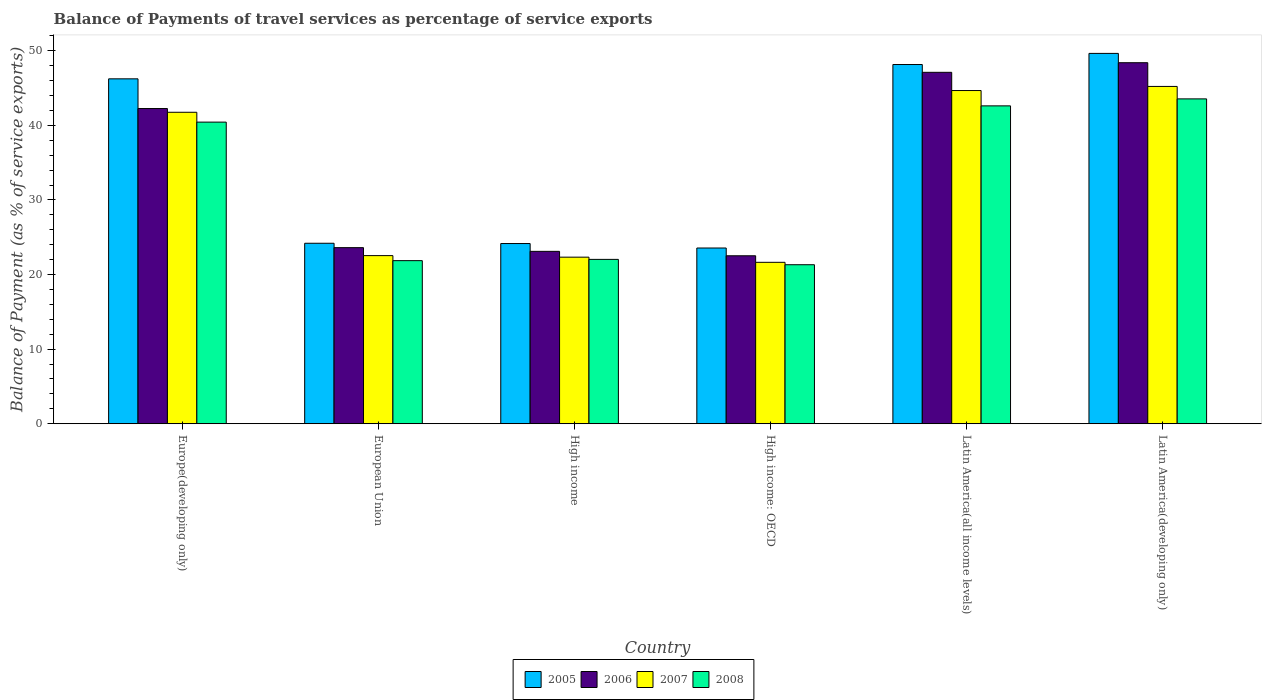How many different coloured bars are there?
Keep it short and to the point. 4. Are the number of bars per tick equal to the number of legend labels?
Provide a succinct answer. Yes. Are the number of bars on each tick of the X-axis equal?
Offer a very short reply. Yes. How many bars are there on the 1st tick from the left?
Your answer should be very brief. 4. How many bars are there on the 3rd tick from the right?
Give a very brief answer. 4. What is the label of the 4th group of bars from the left?
Offer a very short reply. High income: OECD. What is the balance of payments of travel services in 2005 in High income: OECD?
Keep it short and to the point. 23.56. Across all countries, what is the maximum balance of payments of travel services in 2008?
Offer a terse response. 43.55. Across all countries, what is the minimum balance of payments of travel services in 2008?
Provide a succinct answer. 21.32. In which country was the balance of payments of travel services in 2006 maximum?
Your answer should be very brief. Latin America(developing only). In which country was the balance of payments of travel services in 2007 minimum?
Offer a very short reply. High income: OECD. What is the total balance of payments of travel services in 2007 in the graph?
Make the answer very short. 198.15. What is the difference between the balance of payments of travel services in 2006 in High income and that in Latin America(developing only)?
Your answer should be very brief. -25.29. What is the difference between the balance of payments of travel services in 2006 in High income and the balance of payments of travel services in 2008 in Europe(developing only)?
Make the answer very short. -17.33. What is the average balance of payments of travel services in 2006 per country?
Your answer should be very brief. 34.5. What is the difference between the balance of payments of travel services of/in 2007 and balance of payments of travel services of/in 2008 in Latin America(developing only)?
Provide a short and direct response. 1.67. What is the ratio of the balance of payments of travel services in 2007 in Latin America(all income levels) to that in Latin America(developing only)?
Your answer should be very brief. 0.99. Is the balance of payments of travel services in 2006 in Europe(developing only) less than that in High income?
Offer a terse response. No. Is the difference between the balance of payments of travel services in 2007 in High income and Latin America(developing only) greater than the difference between the balance of payments of travel services in 2008 in High income and Latin America(developing only)?
Give a very brief answer. No. What is the difference between the highest and the second highest balance of payments of travel services in 2005?
Your answer should be compact. -1.49. What is the difference between the highest and the lowest balance of payments of travel services in 2007?
Your response must be concise. 23.58. Is the sum of the balance of payments of travel services in 2007 in High income and Latin America(developing only) greater than the maximum balance of payments of travel services in 2005 across all countries?
Offer a terse response. Yes. Is it the case that in every country, the sum of the balance of payments of travel services in 2008 and balance of payments of travel services in 2007 is greater than the sum of balance of payments of travel services in 2005 and balance of payments of travel services in 2006?
Provide a short and direct response. No. How many bars are there?
Keep it short and to the point. 24. Are the values on the major ticks of Y-axis written in scientific E-notation?
Your answer should be very brief. No. Does the graph contain any zero values?
Your response must be concise. No. Where does the legend appear in the graph?
Provide a short and direct response. Bottom center. How are the legend labels stacked?
Your answer should be compact. Horizontal. What is the title of the graph?
Provide a succinct answer. Balance of Payments of travel services as percentage of service exports. What is the label or title of the Y-axis?
Your response must be concise. Balance of Payment (as % of service exports). What is the Balance of Payment (as % of service exports) in 2005 in Europe(developing only)?
Give a very brief answer. 46.24. What is the Balance of Payment (as % of service exports) in 2006 in Europe(developing only)?
Make the answer very short. 42.25. What is the Balance of Payment (as % of service exports) of 2007 in Europe(developing only)?
Provide a succinct answer. 41.76. What is the Balance of Payment (as % of service exports) in 2008 in Europe(developing only)?
Provide a short and direct response. 40.43. What is the Balance of Payment (as % of service exports) of 2005 in European Union?
Provide a succinct answer. 24.19. What is the Balance of Payment (as % of service exports) in 2006 in European Union?
Offer a very short reply. 23.61. What is the Balance of Payment (as % of service exports) of 2007 in European Union?
Make the answer very short. 22.54. What is the Balance of Payment (as % of service exports) in 2008 in European Union?
Offer a very short reply. 21.86. What is the Balance of Payment (as % of service exports) of 2005 in High income?
Provide a short and direct response. 24.16. What is the Balance of Payment (as % of service exports) of 2006 in High income?
Your answer should be compact. 23.11. What is the Balance of Payment (as % of service exports) in 2007 in High income?
Give a very brief answer. 22.33. What is the Balance of Payment (as % of service exports) of 2008 in High income?
Give a very brief answer. 22.03. What is the Balance of Payment (as % of service exports) in 2005 in High income: OECD?
Your answer should be compact. 23.56. What is the Balance of Payment (as % of service exports) of 2006 in High income: OECD?
Your answer should be compact. 22.52. What is the Balance of Payment (as % of service exports) of 2007 in High income: OECD?
Provide a short and direct response. 21.64. What is the Balance of Payment (as % of service exports) in 2008 in High income: OECD?
Your response must be concise. 21.32. What is the Balance of Payment (as % of service exports) in 2005 in Latin America(all income levels)?
Provide a short and direct response. 48.16. What is the Balance of Payment (as % of service exports) of 2006 in Latin America(all income levels)?
Your answer should be compact. 47.11. What is the Balance of Payment (as % of service exports) in 2007 in Latin America(all income levels)?
Ensure brevity in your answer.  44.67. What is the Balance of Payment (as % of service exports) in 2008 in Latin America(all income levels)?
Make the answer very short. 42.61. What is the Balance of Payment (as % of service exports) in 2005 in Latin America(developing only)?
Provide a short and direct response. 49.65. What is the Balance of Payment (as % of service exports) in 2006 in Latin America(developing only)?
Your response must be concise. 48.4. What is the Balance of Payment (as % of service exports) in 2007 in Latin America(developing only)?
Give a very brief answer. 45.22. What is the Balance of Payment (as % of service exports) in 2008 in Latin America(developing only)?
Your response must be concise. 43.55. Across all countries, what is the maximum Balance of Payment (as % of service exports) in 2005?
Ensure brevity in your answer.  49.65. Across all countries, what is the maximum Balance of Payment (as % of service exports) in 2006?
Keep it short and to the point. 48.4. Across all countries, what is the maximum Balance of Payment (as % of service exports) of 2007?
Offer a terse response. 45.22. Across all countries, what is the maximum Balance of Payment (as % of service exports) of 2008?
Your answer should be very brief. 43.55. Across all countries, what is the minimum Balance of Payment (as % of service exports) in 2005?
Make the answer very short. 23.56. Across all countries, what is the minimum Balance of Payment (as % of service exports) of 2006?
Provide a succinct answer. 22.52. Across all countries, what is the minimum Balance of Payment (as % of service exports) in 2007?
Your answer should be very brief. 21.64. Across all countries, what is the minimum Balance of Payment (as % of service exports) in 2008?
Give a very brief answer. 21.32. What is the total Balance of Payment (as % of service exports) of 2005 in the graph?
Your response must be concise. 215.95. What is the total Balance of Payment (as % of service exports) of 2006 in the graph?
Ensure brevity in your answer.  206.99. What is the total Balance of Payment (as % of service exports) of 2007 in the graph?
Provide a succinct answer. 198.15. What is the total Balance of Payment (as % of service exports) of 2008 in the graph?
Your response must be concise. 191.81. What is the difference between the Balance of Payment (as % of service exports) of 2005 in Europe(developing only) and that in European Union?
Offer a very short reply. 22.04. What is the difference between the Balance of Payment (as % of service exports) of 2006 in Europe(developing only) and that in European Union?
Provide a succinct answer. 18.65. What is the difference between the Balance of Payment (as % of service exports) of 2007 in Europe(developing only) and that in European Union?
Your answer should be compact. 19.22. What is the difference between the Balance of Payment (as % of service exports) in 2008 in Europe(developing only) and that in European Union?
Provide a succinct answer. 18.57. What is the difference between the Balance of Payment (as % of service exports) in 2005 in Europe(developing only) and that in High income?
Keep it short and to the point. 22.08. What is the difference between the Balance of Payment (as % of service exports) in 2006 in Europe(developing only) and that in High income?
Give a very brief answer. 19.15. What is the difference between the Balance of Payment (as % of service exports) in 2007 in Europe(developing only) and that in High income?
Give a very brief answer. 19.42. What is the difference between the Balance of Payment (as % of service exports) of 2008 in Europe(developing only) and that in High income?
Offer a terse response. 18.4. What is the difference between the Balance of Payment (as % of service exports) in 2005 in Europe(developing only) and that in High income: OECD?
Provide a short and direct response. 22.68. What is the difference between the Balance of Payment (as % of service exports) in 2006 in Europe(developing only) and that in High income: OECD?
Keep it short and to the point. 19.74. What is the difference between the Balance of Payment (as % of service exports) of 2007 in Europe(developing only) and that in High income: OECD?
Make the answer very short. 20.12. What is the difference between the Balance of Payment (as % of service exports) of 2008 in Europe(developing only) and that in High income: OECD?
Ensure brevity in your answer.  19.12. What is the difference between the Balance of Payment (as % of service exports) in 2005 in Europe(developing only) and that in Latin America(all income levels)?
Provide a succinct answer. -1.92. What is the difference between the Balance of Payment (as % of service exports) of 2006 in Europe(developing only) and that in Latin America(all income levels)?
Your answer should be compact. -4.85. What is the difference between the Balance of Payment (as % of service exports) in 2007 in Europe(developing only) and that in Latin America(all income levels)?
Provide a short and direct response. -2.91. What is the difference between the Balance of Payment (as % of service exports) of 2008 in Europe(developing only) and that in Latin America(all income levels)?
Keep it short and to the point. -2.18. What is the difference between the Balance of Payment (as % of service exports) of 2005 in Europe(developing only) and that in Latin America(developing only)?
Give a very brief answer. -3.41. What is the difference between the Balance of Payment (as % of service exports) in 2006 in Europe(developing only) and that in Latin America(developing only)?
Your answer should be compact. -6.14. What is the difference between the Balance of Payment (as % of service exports) in 2007 in Europe(developing only) and that in Latin America(developing only)?
Your answer should be compact. -3.46. What is the difference between the Balance of Payment (as % of service exports) of 2008 in Europe(developing only) and that in Latin America(developing only)?
Your response must be concise. -3.11. What is the difference between the Balance of Payment (as % of service exports) of 2005 in European Union and that in High income?
Your response must be concise. 0.04. What is the difference between the Balance of Payment (as % of service exports) in 2006 in European Union and that in High income?
Your answer should be compact. 0.5. What is the difference between the Balance of Payment (as % of service exports) in 2007 in European Union and that in High income?
Ensure brevity in your answer.  0.21. What is the difference between the Balance of Payment (as % of service exports) of 2008 in European Union and that in High income?
Keep it short and to the point. -0.17. What is the difference between the Balance of Payment (as % of service exports) in 2005 in European Union and that in High income: OECD?
Give a very brief answer. 0.64. What is the difference between the Balance of Payment (as % of service exports) of 2006 in European Union and that in High income: OECD?
Offer a terse response. 1.09. What is the difference between the Balance of Payment (as % of service exports) in 2007 in European Union and that in High income: OECD?
Your response must be concise. 0.9. What is the difference between the Balance of Payment (as % of service exports) in 2008 in European Union and that in High income: OECD?
Your answer should be very brief. 0.55. What is the difference between the Balance of Payment (as % of service exports) of 2005 in European Union and that in Latin America(all income levels)?
Your answer should be very brief. -23.96. What is the difference between the Balance of Payment (as % of service exports) of 2006 in European Union and that in Latin America(all income levels)?
Ensure brevity in your answer.  -23.5. What is the difference between the Balance of Payment (as % of service exports) of 2007 in European Union and that in Latin America(all income levels)?
Give a very brief answer. -22.13. What is the difference between the Balance of Payment (as % of service exports) of 2008 in European Union and that in Latin America(all income levels)?
Make the answer very short. -20.75. What is the difference between the Balance of Payment (as % of service exports) in 2005 in European Union and that in Latin America(developing only)?
Offer a very short reply. -25.45. What is the difference between the Balance of Payment (as % of service exports) in 2006 in European Union and that in Latin America(developing only)?
Make the answer very short. -24.79. What is the difference between the Balance of Payment (as % of service exports) of 2007 in European Union and that in Latin America(developing only)?
Ensure brevity in your answer.  -22.68. What is the difference between the Balance of Payment (as % of service exports) of 2008 in European Union and that in Latin America(developing only)?
Your answer should be very brief. -21.68. What is the difference between the Balance of Payment (as % of service exports) in 2005 in High income and that in High income: OECD?
Provide a short and direct response. 0.6. What is the difference between the Balance of Payment (as % of service exports) in 2006 in High income and that in High income: OECD?
Provide a succinct answer. 0.59. What is the difference between the Balance of Payment (as % of service exports) in 2007 in High income and that in High income: OECD?
Make the answer very short. 0.69. What is the difference between the Balance of Payment (as % of service exports) of 2008 in High income and that in High income: OECD?
Offer a terse response. 0.72. What is the difference between the Balance of Payment (as % of service exports) in 2005 in High income and that in Latin America(all income levels)?
Your answer should be compact. -24. What is the difference between the Balance of Payment (as % of service exports) in 2006 in High income and that in Latin America(all income levels)?
Keep it short and to the point. -24. What is the difference between the Balance of Payment (as % of service exports) in 2007 in High income and that in Latin America(all income levels)?
Your answer should be compact. -22.34. What is the difference between the Balance of Payment (as % of service exports) of 2008 in High income and that in Latin America(all income levels)?
Provide a short and direct response. -20.58. What is the difference between the Balance of Payment (as % of service exports) in 2005 in High income and that in Latin America(developing only)?
Your response must be concise. -25.49. What is the difference between the Balance of Payment (as % of service exports) of 2006 in High income and that in Latin America(developing only)?
Offer a very short reply. -25.29. What is the difference between the Balance of Payment (as % of service exports) in 2007 in High income and that in Latin America(developing only)?
Offer a terse response. -22.89. What is the difference between the Balance of Payment (as % of service exports) in 2008 in High income and that in Latin America(developing only)?
Make the answer very short. -21.52. What is the difference between the Balance of Payment (as % of service exports) in 2005 in High income: OECD and that in Latin America(all income levels)?
Give a very brief answer. -24.6. What is the difference between the Balance of Payment (as % of service exports) in 2006 in High income: OECD and that in Latin America(all income levels)?
Keep it short and to the point. -24.59. What is the difference between the Balance of Payment (as % of service exports) in 2007 in High income: OECD and that in Latin America(all income levels)?
Ensure brevity in your answer.  -23.03. What is the difference between the Balance of Payment (as % of service exports) in 2008 in High income: OECD and that in Latin America(all income levels)?
Make the answer very short. -21.29. What is the difference between the Balance of Payment (as % of service exports) of 2005 in High income: OECD and that in Latin America(developing only)?
Provide a succinct answer. -26.09. What is the difference between the Balance of Payment (as % of service exports) in 2006 in High income: OECD and that in Latin America(developing only)?
Provide a short and direct response. -25.88. What is the difference between the Balance of Payment (as % of service exports) of 2007 in High income: OECD and that in Latin America(developing only)?
Your response must be concise. -23.58. What is the difference between the Balance of Payment (as % of service exports) in 2008 in High income: OECD and that in Latin America(developing only)?
Provide a short and direct response. -22.23. What is the difference between the Balance of Payment (as % of service exports) in 2005 in Latin America(all income levels) and that in Latin America(developing only)?
Offer a terse response. -1.49. What is the difference between the Balance of Payment (as % of service exports) in 2006 in Latin America(all income levels) and that in Latin America(developing only)?
Your response must be concise. -1.29. What is the difference between the Balance of Payment (as % of service exports) in 2007 in Latin America(all income levels) and that in Latin America(developing only)?
Your response must be concise. -0.55. What is the difference between the Balance of Payment (as % of service exports) of 2008 in Latin America(all income levels) and that in Latin America(developing only)?
Provide a succinct answer. -0.94. What is the difference between the Balance of Payment (as % of service exports) of 2005 in Europe(developing only) and the Balance of Payment (as % of service exports) of 2006 in European Union?
Provide a succinct answer. 22.63. What is the difference between the Balance of Payment (as % of service exports) in 2005 in Europe(developing only) and the Balance of Payment (as % of service exports) in 2007 in European Union?
Keep it short and to the point. 23.7. What is the difference between the Balance of Payment (as % of service exports) in 2005 in Europe(developing only) and the Balance of Payment (as % of service exports) in 2008 in European Union?
Your answer should be compact. 24.37. What is the difference between the Balance of Payment (as % of service exports) in 2006 in Europe(developing only) and the Balance of Payment (as % of service exports) in 2007 in European Union?
Give a very brief answer. 19.72. What is the difference between the Balance of Payment (as % of service exports) in 2006 in Europe(developing only) and the Balance of Payment (as % of service exports) in 2008 in European Union?
Offer a very short reply. 20.39. What is the difference between the Balance of Payment (as % of service exports) in 2007 in Europe(developing only) and the Balance of Payment (as % of service exports) in 2008 in European Union?
Your answer should be compact. 19.89. What is the difference between the Balance of Payment (as % of service exports) of 2005 in Europe(developing only) and the Balance of Payment (as % of service exports) of 2006 in High income?
Provide a short and direct response. 23.13. What is the difference between the Balance of Payment (as % of service exports) in 2005 in Europe(developing only) and the Balance of Payment (as % of service exports) in 2007 in High income?
Offer a very short reply. 23.91. What is the difference between the Balance of Payment (as % of service exports) of 2005 in Europe(developing only) and the Balance of Payment (as % of service exports) of 2008 in High income?
Give a very brief answer. 24.2. What is the difference between the Balance of Payment (as % of service exports) in 2006 in Europe(developing only) and the Balance of Payment (as % of service exports) in 2007 in High income?
Give a very brief answer. 19.92. What is the difference between the Balance of Payment (as % of service exports) in 2006 in Europe(developing only) and the Balance of Payment (as % of service exports) in 2008 in High income?
Your answer should be compact. 20.22. What is the difference between the Balance of Payment (as % of service exports) in 2007 in Europe(developing only) and the Balance of Payment (as % of service exports) in 2008 in High income?
Provide a short and direct response. 19.72. What is the difference between the Balance of Payment (as % of service exports) in 2005 in Europe(developing only) and the Balance of Payment (as % of service exports) in 2006 in High income: OECD?
Your answer should be very brief. 23.72. What is the difference between the Balance of Payment (as % of service exports) of 2005 in Europe(developing only) and the Balance of Payment (as % of service exports) of 2007 in High income: OECD?
Offer a terse response. 24.6. What is the difference between the Balance of Payment (as % of service exports) in 2005 in Europe(developing only) and the Balance of Payment (as % of service exports) in 2008 in High income: OECD?
Give a very brief answer. 24.92. What is the difference between the Balance of Payment (as % of service exports) of 2006 in Europe(developing only) and the Balance of Payment (as % of service exports) of 2007 in High income: OECD?
Your answer should be compact. 20.62. What is the difference between the Balance of Payment (as % of service exports) of 2006 in Europe(developing only) and the Balance of Payment (as % of service exports) of 2008 in High income: OECD?
Your answer should be very brief. 20.94. What is the difference between the Balance of Payment (as % of service exports) of 2007 in Europe(developing only) and the Balance of Payment (as % of service exports) of 2008 in High income: OECD?
Your answer should be very brief. 20.44. What is the difference between the Balance of Payment (as % of service exports) in 2005 in Europe(developing only) and the Balance of Payment (as % of service exports) in 2006 in Latin America(all income levels)?
Make the answer very short. -0.87. What is the difference between the Balance of Payment (as % of service exports) in 2005 in Europe(developing only) and the Balance of Payment (as % of service exports) in 2007 in Latin America(all income levels)?
Ensure brevity in your answer.  1.57. What is the difference between the Balance of Payment (as % of service exports) of 2005 in Europe(developing only) and the Balance of Payment (as % of service exports) of 2008 in Latin America(all income levels)?
Offer a very short reply. 3.62. What is the difference between the Balance of Payment (as % of service exports) in 2006 in Europe(developing only) and the Balance of Payment (as % of service exports) in 2007 in Latin America(all income levels)?
Your response must be concise. -2.41. What is the difference between the Balance of Payment (as % of service exports) in 2006 in Europe(developing only) and the Balance of Payment (as % of service exports) in 2008 in Latin America(all income levels)?
Offer a very short reply. -0.36. What is the difference between the Balance of Payment (as % of service exports) in 2007 in Europe(developing only) and the Balance of Payment (as % of service exports) in 2008 in Latin America(all income levels)?
Provide a succinct answer. -0.86. What is the difference between the Balance of Payment (as % of service exports) of 2005 in Europe(developing only) and the Balance of Payment (as % of service exports) of 2006 in Latin America(developing only)?
Ensure brevity in your answer.  -2.16. What is the difference between the Balance of Payment (as % of service exports) in 2005 in Europe(developing only) and the Balance of Payment (as % of service exports) in 2007 in Latin America(developing only)?
Your response must be concise. 1.02. What is the difference between the Balance of Payment (as % of service exports) of 2005 in Europe(developing only) and the Balance of Payment (as % of service exports) of 2008 in Latin America(developing only)?
Give a very brief answer. 2.69. What is the difference between the Balance of Payment (as % of service exports) of 2006 in Europe(developing only) and the Balance of Payment (as % of service exports) of 2007 in Latin America(developing only)?
Your answer should be very brief. -2.96. What is the difference between the Balance of Payment (as % of service exports) in 2006 in Europe(developing only) and the Balance of Payment (as % of service exports) in 2008 in Latin America(developing only)?
Provide a succinct answer. -1.29. What is the difference between the Balance of Payment (as % of service exports) in 2007 in Europe(developing only) and the Balance of Payment (as % of service exports) in 2008 in Latin America(developing only)?
Provide a short and direct response. -1.79. What is the difference between the Balance of Payment (as % of service exports) of 2005 in European Union and the Balance of Payment (as % of service exports) of 2006 in High income?
Provide a short and direct response. 1.09. What is the difference between the Balance of Payment (as % of service exports) in 2005 in European Union and the Balance of Payment (as % of service exports) in 2007 in High income?
Ensure brevity in your answer.  1.86. What is the difference between the Balance of Payment (as % of service exports) of 2005 in European Union and the Balance of Payment (as % of service exports) of 2008 in High income?
Provide a succinct answer. 2.16. What is the difference between the Balance of Payment (as % of service exports) of 2006 in European Union and the Balance of Payment (as % of service exports) of 2007 in High income?
Your answer should be very brief. 1.28. What is the difference between the Balance of Payment (as % of service exports) in 2006 in European Union and the Balance of Payment (as % of service exports) in 2008 in High income?
Ensure brevity in your answer.  1.57. What is the difference between the Balance of Payment (as % of service exports) in 2007 in European Union and the Balance of Payment (as % of service exports) in 2008 in High income?
Offer a terse response. 0.5. What is the difference between the Balance of Payment (as % of service exports) of 2005 in European Union and the Balance of Payment (as % of service exports) of 2006 in High income: OECD?
Give a very brief answer. 1.68. What is the difference between the Balance of Payment (as % of service exports) in 2005 in European Union and the Balance of Payment (as % of service exports) in 2007 in High income: OECD?
Your answer should be compact. 2.56. What is the difference between the Balance of Payment (as % of service exports) of 2005 in European Union and the Balance of Payment (as % of service exports) of 2008 in High income: OECD?
Keep it short and to the point. 2.88. What is the difference between the Balance of Payment (as % of service exports) in 2006 in European Union and the Balance of Payment (as % of service exports) in 2007 in High income: OECD?
Offer a terse response. 1.97. What is the difference between the Balance of Payment (as % of service exports) of 2006 in European Union and the Balance of Payment (as % of service exports) of 2008 in High income: OECD?
Ensure brevity in your answer.  2.29. What is the difference between the Balance of Payment (as % of service exports) in 2007 in European Union and the Balance of Payment (as % of service exports) in 2008 in High income: OECD?
Your answer should be compact. 1.22. What is the difference between the Balance of Payment (as % of service exports) of 2005 in European Union and the Balance of Payment (as % of service exports) of 2006 in Latin America(all income levels)?
Make the answer very short. -22.91. What is the difference between the Balance of Payment (as % of service exports) in 2005 in European Union and the Balance of Payment (as % of service exports) in 2007 in Latin America(all income levels)?
Your answer should be very brief. -20.47. What is the difference between the Balance of Payment (as % of service exports) of 2005 in European Union and the Balance of Payment (as % of service exports) of 2008 in Latin America(all income levels)?
Keep it short and to the point. -18.42. What is the difference between the Balance of Payment (as % of service exports) of 2006 in European Union and the Balance of Payment (as % of service exports) of 2007 in Latin America(all income levels)?
Provide a succinct answer. -21.06. What is the difference between the Balance of Payment (as % of service exports) in 2006 in European Union and the Balance of Payment (as % of service exports) in 2008 in Latin America(all income levels)?
Your response must be concise. -19.01. What is the difference between the Balance of Payment (as % of service exports) in 2007 in European Union and the Balance of Payment (as % of service exports) in 2008 in Latin America(all income levels)?
Make the answer very short. -20.07. What is the difference between the Balance of Payment (as % of service exports) in 2005 in European Union and the Balance of Payment (as % of service exports) in 2006 in Latin America(developing only)?
Ensure brevity in your answer.  -24.2. What is the difference between the Balance of Payment (as % of service exports) in 2005 in European Union and the Balance of Payment (as % of service exports) in 2007 in Latin America(developing only)?
Provide a short and direct response. -21.02. What is the difference between the Balance of Payment (as % of service exports) in 2005 in European Union and the Balance of Payment (as % of service exports) in 2008 in Latin America(developing only)?
Provide a succinct answer. -19.35. What is the difference between the Balance of Payment (as % of service exports) in 2006 in European Union and the Balance of Payment (as % of service exports) in 2007 in Latin America(developing only)?
Provide a succinct answer. -21.61. What is the difference between the Balance of Payment (as % of service exports) in 2006 in European Union and the Balance of Payment (as % of service exports) in 2008 in Latin America(developing only)?
Ensure brevity in your answer.  -19.94. What is the difference between the Balance of Payment (as % of service exports) in 2007 in European Union and the Balance of Payment (as % of service exports) in 2008 in Latin America(developing only)?
Keep it short and to the point. -21.01. What is the difference between the Balance of Payment (as % of service exports) in 2005 in High income and the Balance of Payment (as % of service exports) in 2006 in High income: OECD?
Give a very brief answer. 1.64. What is the difference between the Balance of Payment (as % of service exports) of 2005 in High income and the Balance of Payment (as % of service exports) of 2007 in High income: OECD?
Provide a succinct answer. 2.52. What is the difference between the Balance of Payment (as % of service exports) of 2005 in High income and the Balance of Payment (as % of service exports) of 2008 in High income: OECD?
Your answer should be very brief. 2.84. What is the difference between the Balance of Payment (as % of service exports) of 2006 in High income and the Balance of Payment (as % of service exports) of 2007 in High income: OECD?
Your answer should be compact. 1.47. What is the difference between the Balance of Payment (as % of service exports) of 2006 in High income and the Balance of Payment (as % of service exports) of 2008 in High income: OECD?
Provide a succinct answer. 1.79. What is the difference between the Balance of Payment (as % of service exports) in 2007 in High income and the Balance of Payment (as % of service exports) in 2008 in High income: OECD?
Ensure brevity in your answer.  1.01. What is the difference between the Balance of Payment (as % of service exports) in 2005 in High income and the Balance of Payment (as % of service exports) in 2006 in Latin America(all income levels)?
Ensure brevity in your answer.  -22.95. What is the difference between the Balance of Payment (as % of service exports) of 2005 in High income and the Balance of Payment (as % of service exports) of 2007 in Latin America(all income levels)?
Provide a succinct answer. -20.51. What is the difference between the Balance of Payment (as % of service exports) in 2005 in High income and the Balance of Payment (as % of service exports) in 2008 in Latin America(all income levels)?
Keep it short and to the point. -18.45. What is the difference between the Balance of Payment (as % of service exports) of 2006 in High income and the Balance of Payment (as % of service exports) of 2007 in Latin America(all income levels)?
Give a very brief answer. -21.56. What is the difference between the Balance of Payment (as % of service exports) in 2006 in High income and the Balance of Payment (as % of service exports) in 2008 in Latin America(all income levels)?
Keep it short and to the point. -19.5. What is the difference between the Balance of Payment (as % of service exports) in 2007 in High income and the Balance of Payment (as % of service exports) in 2008 in Latin America(all income levels)?
Keep it short and to the point. -20.28. What is the difference between the Balance of Payment (as % of service exports) of 2005 in High income and the Balance of Payment (as % of service exports) of 2006 in Latin America(developing only)?
Your answer should be compact. -24.24. What is the difference between the Balance of Payment (as % of service exports) in 2005 in High income and the Balance of Payment (as % of service exports) in 2007 in Latin America(developing only)?
Your answer should be compact. -21.06. What is the difference between the Balance of Payment (as % of service exports) of 2005 in High income and the Balance of Payment (as % of service exports) of 2008 in Latin America(developing only)?
Offer a very short reply. -19.39. What is the difference between the Balance of Payment (as % of service exports) of 2006 in High income and the Balance of Payment (as % of service exports) of 2007 in Latin America(developing only)?
Keep it short and to the point. -22.11. What is the difference between the Balance of Payment (as % of service exports) in 2006 in High income and the Balance of Payment (as % of service exports) in 2008 in Latin America(developing only)?
Ensure brevity in your answer.  -20.44. What is the difference between the Balance of Payment (as % of service exports) in 2007 in High income and the Balance of Payment (as % of service exports) in 2008 in Latin America(developing only)?
Make the answer very short. -21.22. What is the difference between the Balance of Payment (as % of service exports) in 2005 in High income: OECD and the Balance of Payment (as % of service exports) in 2006 in Latin America(all income levels)?
Make the answer very short. -23.55. What is the difference between the Balance of Payment (as % of service exports) in 2005 in High income: OECD and the Balance of Payment (as % of service exports) in 2007 in Latin America(all income levels)?
Provide a short and direct response. -21.11. What is the difference between the Balance of Payment (as % of service exports) of 2005 in High income: OECD and the Balance of Payment (as % of service exports) of 2008 in Latin America(all income levels)?
Provide a short and direct response. -19.05. What is the difference between the Balance of Payment (as % of service exports) in 2006 in High income: OECD and the Balance of Payment (as % of service exports) in 2007 in Latin America(all income levels)?
Provide a short and direct response. -22.15. What is the difference between the Balance of Payment (as % of service exports) of 2006 in High income: OECD and the Balance of Payment (as % of service exports) of 2008 in Latin America(all income levels)?
Your answer should be compact. -20.1. What is the difference between the Balance of Payment (as % of service exports) in 2007 in High income: OECD and the Balance of Payment (as % of service exports) in 2008 in Latin America(all income levels)?
Ensure brevity in your answer.  -20.97. What is the difference between the Balance of Payment (as % of service exports) in 2005 in High income: OECD and the Balance of Payment (as % of service exports) in 2006 in Latin America(developing only)?
Your response must be concise. -24.84. What is the difference between the Balance of Payment (as % of service exports) in 2005 in High income: OECD and the Balance of Payment (as % of service exports) in 2007 in Latin America(developing only)?
Keep it short and to the point. -21.66. What is the difference between the Balance of Payment (as % of service exports) of 2005 in High income: OECD and the Balance of Payment (as % of service exports) of 2008 in Latin America(developing only)?
Your answer should be compact. -19.99. What is the difference between the Balance of Payment (as % of service exports) in 2006 in High income: OECD and the Balance of Payment (as % of service exports) in 2007 in Latin America(developing only)?
Your response must be concise. -22.7. What is the difference between the Balance of Payment (as % of service exports) in 2006 in High income: OECD and the Balance of Payment (as % of service exports) in 2008 in Latin America(developing only)?
Your answer should be very brief. -21.03. What is the difference between the Balance of Payment (as % of service exports) in 2007 in High income: OECD and the Balance of Payment (as % of service exports) in 2008 in Latin America(developing only)?
Offer a very short reply. -21.91. What is the difference between the Balance of Payment (as % of service exports) in 2005 in Latin America(all income levels) and the Balance of Payment (as % of service exports) in 2006 in Latin America(developing only)?
Make the answer very short. -0.24. What is the difference between the Balance of Payment (as % of service exports) of 2005 in Latin America(all income levels) and the Balance of Payment (as % of service exports) of 2007 in Latin America(developing only)?
Ensure brevity in your answer.  2.94. What is the difference between the Balance of Payment (as % of service exports) in 2005 in Latin America(all income levels) and the Balance of Payment (as % of service exports) in 2008 in Latin America(developing only)?
Give a very brief answer. 4.61. What is the difference between the Balance of Payment (as % of service exports) of 2006 in Latin America(all income levels) and the Balance of Payment (as % of service exports) of 2007 in Latin America(developing only)?
Give a very brief answer. 1.89. What is the difference between the Balance of Payment (as % of service exports) in 2006 in Latin America(all income levels) and the Balance of Payment (as % of service exports) in 2008 in Latin America(developing only)?
Give a very brief answer. 3.56. What is the difference between the Balance of Payment (as % of service exports) in 2007 in Latin America(all income levels) and the Balance of Payment (as % of service exports) in 2008 in Latin America(developing only)?
Your response must be concise. 1.12. What is the average Balance of Payment (as % of service exports) of 2005 per country?
Ensure brevity in your answer.  35.99. What is the average Balance of Payment (as % of service exports) in 2006 per country?
Give a very brief answer. 34.5. What is the average Balance of Payment (as % of service exports) in 2007 per country?
Keep it short and to the point. 33.02. What is the average Balance of Payment (as % of service exports) of 2008 per country?
Offer a terse response. 31.97. What is the difference between the Balance of Payment (as % of service exports) in 2005 and Balance of Payment (as % of service exports) in 2006 in Europe(developing only)?
Offer a terse response. 3.98. What is the difference between the Balance of Payment (as % of service exports) of 2005 and Balance of Payment (as % of service exports) of 2007 in Europe(developing only)?
Make the answer very short. 4.48. What is the difference between the Balance of Payment (as % of service exports) of 2005 and Balance of Payment (as % of service exports) of 2008 in Europe(developing only)?
Offer a terse response. 5.8. What is the difference between the Balance of Payment (as % of service exports) of 2006 and Balance of Payment (as % of service exports) of 2007 in Europe(developing only)?
Ensure brevity in your answer.  0.5. What is the difference between the Balance of Payment (as % of service exports) of 2006 and Balance of Payment (as % of service exports) of 2008 in Europe(developing only)?
Offer a very short reply. 1.82. What is the difference between the Balance of Payment (as % of service exports) in 2007 and Balance of Payment (as % of service exports) in 2008 in Europe(developing only)?
Provide a short and direct response. 1.32. What is the difference between the Balance of Payment (as % of service exports) in 2005 and Balance of Payment (as % of service exports) in 2006 in European Union?
Give a very brief answer. 0.59. What is the difference between the Balance of Payment (as % of service exports) of 2005 and Balance of Payment (as % of service exports) of 2007 in European Union?
Offer a terse response. 1.66. What is the difference between the Balance of Payment (as % of service exports) of 2005 and Balance of Payment (as % of service exports) of 2008 in European Union?
Make the answer very short. 2.33. What is the difference between the Balance of Payment (as % of service exports) in 2006 and Balance of Payment (as % of service exports) in 2007 in European Union?
Make the answer very short. 1.07. What is the difference between the Balance of Payment (as % of service exports) of 2006 and Balance of Payment (as % of service exports) of 2008 in European Union?
Provide a succinct answer. 1.74. What is the difference between the Balance of Payment (as % of service exports) of 2007 and Balance of Payment (as % of service exports) of 2008 in European Union?
Your answer should be compact. 0.67. What is the difference between the Balance of Payment (as % of service exports) of 2005 and Balance of Payment (as % of service exports) of 2006 in High income?
Provide a short and direct response. 1.05. What is the difference between the Balance of Payment (as % of service exports) of 2005 and Balance of Payment (as % of service exports) of 2007 in High income?
Your answer should be compact. 1.83. What is the difference between the Balance of Payment (as % of service exports) in 2005 and Balance of Payment (as % of service exports) in 2008 in High income?
Offer a very short reply. 2.13. What is the difference between the Balance of Payment (as % of service exports) in 2006 and Balance of Payment (as % of service exports) in 2007 in High income?
Make the answer very short. 0.78. What is the difference between the Balance of Payment (as % of service exports) of 2006 and Balance of Payment (as % of service exports) of 2008 in High income?
Give a very brief answer. 1.08. What is the difference between the Balance of Payment (as % of service exports) in 2007 and Balance of Payment (as % of service exports) in 2008 in High income?
Provide a short and direct response. 0.3. What is the difference between the Balance of Payment (as % of service exports) in 2005 and Balance of Payment (as % of service exports) in 2006 in High income: OECD?
Provide a short and direct response. 1.04. What is the difference between the Balance of Payment (as % of service exports) in 2005 and Balance of Payment (as % of service exports) in 2007 in High income: OECD?
Provide a short and direct response. 1.92. What is the difference between the Balance of Payment (as % of service exports) in 2005 and Balance of Payment (as % of service exports) in 2008 in High income: OECD?
Keep it short and to the point. 2.24. What is the difference between the Balance of Payment (as % of service exports) in 2006 and Balance of Payment (as % of service exports) in 2007 in High income: OECD?
Ensure brevity in your answer.  0.88. What is the difference between the Balance of Payment (as % of service exports) in 2006 and Balance of Payment (as % of service exports) in 2008 in High income: OECD?
Your answer should be compact. 1.2. What is the difference between the Balance of Payment (as % of service exports) in 2007 and Balance of Payment (as % of service exports) in 2008 in High income: OECD?
Keep it short and to the point. 0.32. What is the difference between the Balance of Payment (as % of service exports) in 2005 and Balance of Payment (as % of service exports) in 2006 in Latin America(all income levels)?
Provide a succinct answer. 1.05. What is the difference between the Balance of Payment (as % of service exports) of 2005 and Balance of Payment (as % of service exports) of 2007 in Latin America(all income levels)?
Offer a very short reply. 3.49. What is the difference between the Balance of Payment (as % of service exports) of 2005 and Balance of Payment (as % of service exports) of 2008 in Latin America(all income levels)?
Offer a very short reply. 5.54. What is the difference between the Balance of Payment (as % of service exports) of 2006 and Balance of Payment (as % of service exports) of 2007 in Latin America(all income levels)?
Offer a very short reply. 2.44. What is the difference between the Balance of Payment (as % of service exports) of 2006 and Balance of Payment (as % of service exports) of 2008 in Latin America(all income levels)?
Keep it short and to the point. 4.5. What is the difference between the Balance of Payment (as % of service exports) of 2007 and Balance of Payment (as % of service exports) of 2008 in Latin America(all income levels)?
Offer a terse response. 2.05. What is the difference between the Balance of Payment (as % of service exports) of 2005 and Balance of Payment (as % of service exports) of 2006 in Latin America(developing only)?
Give a very brief answer. 1.25. What is the difference between the Balance of Payment (as % of service exports) of 2005 and Balance of Payment (as % of service exports) of 2007 in Latin America(developing only)?
Keep it short and to the point. 4.43. What is the difference between the Balance of Payment (as % of service exports) of 2005 and Balance of Payment (as % of service exports) of 2008 in Latin America(developing only)?
Offer a very short reply. 6.1. What is the difference between the Balance of Payment (as % of service exports) of 2006 and Balance of Payment (as % of service exports) of 2007 in Latin America(developing only)?
Keep it short and to the point. 3.18. What is the difference between the Balance of Payment (as % of service exports) of 2006 and Balance of Payment (as % of service exports) of 2008 in Latin America(developing only)?
Provide a short and direct response. 4.85. What is the difference between the Balance of Payment (as % of service exports) of 2007 and Balance of Payment (as % of service exports) of 2008 in Latin America(developing only)?
Your answer should be compact. 1.67. What is the ratio of the Balance of Payment (as % of service exports) in 2005 in Europe(developing only) to that in European Union?
Offer a very short reply. 1.91. What is the ratio of the Balance of Payment (as % of service exports) in 2006 in Europe(developing only) to that in European Union?
Ensure brevity in your answer.  1.79. What is the ratio of the Balance of Payment (as % of service exports) in 2007 in Europe(developing only) to that in European Union?
Offer a terse response. 1.85. What is the ratio of the Balance of Payment (as % of service exports) in 2008 in Europe(developing only) to that in European Union?
Your answer should be compact. 1.85. What is the ratio of the Balance of Payment (as % of service exports) of 2005 in Europe(developing only) to that in High income?
Offer a terse response. 1.91. What is the ratio of the Balance of Payment (as % of service exports) of 2006 in Europe(developing only) to that in High income?
Your response must be concise. 1.83. What is the ratio of the Balance of Payment (as % of service exports) in 2007 in Europe(developing only) to that in High income?
Keep it short and to the point. 1.87. What is the ratio of the Balance of Payment (as % of service exports) in 2008 in Europe(developing only) to that in High income?
Make the answer very short. 1.84. What is the ratio of the Balance of Payment (as % of service exports) in 2005 in Europe(developing only) to that in High income: OECD?
Your response must be concise. 1.96. What is the ratio of the Balance of Payment (as % of service exports) of 2006 in Europe(developing only) to that in High income: OECD?
Provide a short and direct response. 1.88. What is the ratio of the Balance of Payment (as % of service exports) in 2007 in Europe(developing only) to that in High income: OECD?
Your answer should be compact. 1.93. What is the ratio of the Balance of Payment (as % of service exports) in 2008 in Europe(developing only) to that in High income: OECD?
Your answer should be very brief. 1.9. What is the ratio of the Balance of Payment (as % of service exports) in 2005 in Europe(developing only) to that in Latin America(all income levels)?
Make the answer very short. 0.96. What is the ratio of the Balance of Payment (as % of service exports) in 2006 in Europe(developing only) to that in Latin America(all income levels)?
Offer a terse response. 0.9. What is the ratio of the Balance of Payment (as % of service exports) in 2007 in Europe(developing only) to that in Latin America(all income levels)?
Your answer should be very brief. 0.93. What is the ratio of the Balance of Payment (as % of service exports) in 2008 in Europe(developing only) to that in Latin America(all income levels)?
Offer a terse response. 0.95. What is the ratio of the Balance of Payment (as % of service exports) in 2005 in Europe(developing only) to that in Latin America(developing only)?
Provide a succinct answer. 0.93. What is the ratio of the Balance of Payment (as % of service exports) in 2006 in Europe(developing only) to that in Latin America(developing only)?
Your response must be concise. 0.87. What is the ratio of the Balance of Payment (as % of service exports) of 2007 in Europe(developing only) to that in Latin America(developing only)?
Offer a terse response. 0.92. What is the ratio of the Balance of Payment (as % of service exports) in 2008 in Europe(developing only) to that in Latin America(developing only)?
Provide a short and direct response. 0.93. What is the ratio of the Balance of Payment (as % of service exports) in 2005 in European Union to that in High income?
Provide a short and direct response. 1. What is the ratio of the Balance of Payment (as % of service exports) in 2006 in European Union to that in High income?
Ensure brevity in your answer.  1.02. What is the ratio of the Balance of Payment (as % of service exports) in 2007 in European Union to that in High income?
Your answer should be very brief. 1.01. What is the ratio of the Balance of Payment (as % of service exports) in 2008 in European Union to that in High income?
Make the answer very short. 0.99. What is the ratio of the Balance of Payment (as % of service exports) of 2006 in European Union to that in High income: OECD?
Ensure brevity in your answer.  1.05. What is the ratio of the Balance of Payment (as % of service exports) of 2007 in European Union to that in High income: OECD?
Give a very brief answer. 1.04. What is the ratio of the Balance of Payment (as % of service exports) in 2008 in European Union to that in High income: OECD?
Offer a terse response. 1.03. What is the ratio of the Balance of Payment (as % of service exports) of 2005 in European Union to that in Latin America(all income levels)?
Keep it short and to the point. 0.5. What is the ratio of the Balance of Payment (as % of service exports) of 2006 in European Union to that in Latin America(all income levels)?
Your response must be concise. 0.5. What is the ratio of the Balance of Payment (as % of service exports) of 2007 in European Union to that in Latin America(all income levels)?
Your response must be concise. 0.5. What is the ratio of the Balance of Payment (as % of service exports) in 2008 in European Union to that in Latin America(all income levels)?
Provide a succinct answer. 0.51. What is the ratio of the Balance of Payment (as % of service exports) in 2005 in European Union to that in Latin America(developing only)?
Your response must be concise. 0.49. What is the ratio of the Balance of Payment (as % of service exports) of 2006 in European Union to that in Latin America(developing only)?
Offer a terse response. 0.49. What is the ratio of the Balance of Payment (as % of service exports) in 2007 in European Union to that in Latin America(developing only)?
Your answer should be compact. 0.5. What is the ratio of the Balance of Payment (as % of service exports) of 2008 in European Union to that in Latin America(developing only)?
Provide a succinct answer. 0.5. What is the ratio of the Balance of Payment (as % of service exports) in 2005 in High income to that in High income: OECD?
Keep it short and to the point. 1.03. What is the ratio of the Balance of Payment (as % of service exports) in 2006 in High income to that in High income: OECD?
Offer a terse response. 1.03. What is the ratio of the Balance of Payment (as % of service exports) in 2007 in High income to that in High income: OECD?
Your response must be concise. 1.03. What is the ratio of the Balance of Payment (as % of service exports) in 2008 in High income to that in High income: OECD?
Offer a very short reply. 1.03. What is the ratio of the Balance of Payment (as % of service exports) of 2005 in High income to that in Latin America(all income levels)?
Offer a terse response. 0.5. What is the ratio of the Balance of Payment (as % of service exports) in 2006 in High income to that in Latin America(all income levels)?
Your answer should be very brief. 0.49. What is the ratio of the Balance of Payment (as % of service exports) of 2007 in High income to that in Latin America(all income levels)?
Offer a terse response. 0.5. What is the ratio of the Balance of Payment (as % of service exports) in 2008 in High income to that in Latin America(all income levels)?
Keep it short and to the point. 0.52. What is the ratio of the Balance of Payment (as % of service exports) of 2005 in High income to that in Latin America(developing only)?
Offer a terse response. 0.49. What is the ratio of the Balance of Payment (as % of service exports) in 2006 in High income to that in Latin America(developing only)?
Your response must be concise. 0.48. What is the ratio of the Balance of Payment (as % of service exports) in 2007 in High income to that in Latin America(developing only)?
Make the answer very short. 0.49. What is the ratio of the Balance of Payment (as % of service exports) in 2008 in High income to that in Latin America(developing only)?
Your response must be concise. 0.51. What is the ratio of the Balance of Payment (as % of service exports) of 2005 in High income: OECD to that in Latin America(all income levels)?
Give a very brief answer. 0.49. What is the ratio of the Balance of Payment (as % of service exports) of 2006 in High income: OECD to that in Latin America(all income levels)?
Offer a very short reply. 0.48. What is the ratio of the Balance of Payment (as % of service exports) in 2007 in High income: OECD to that in Latin America(all income levels)?
Keep it short and to the point. 0.48. What is the ratio of the Balance of Payment (as % of service exports) in 2008 in High income: OECD to that in Latin America(all income levels)?
Provide a succinct answer. 0.5. What is the ratio of the Balance of Payment (as % of service exports) in 2005 in High income: OECD to that in Latin America(developing only)?
Give a very brief answer. 0.47. What is the ratio of the Balance of Payment (as % of service exports) in 2006 in High income: OECD to that in Latin America(developing only)?
Provide a succinct answer. 0.47. What is the ratio of the Balance of Payment (as % of service exports) of 2007 in High income: OECD to that in Latin America(developing only)?
Make the answer very short. 0.48. What is the ratio of the Balance of Payment (as % of service exports) in 2008 in High income: OECD to that in Latin America(developing only)?
Provide a succinct answer. 0.49. What is the ratio of the Balance of Payment (as % of service exports) in 2005 in Latin America(all income levels) to that in Latin America(developing only)?
Your answer should be very brief. 0.97. What is the ratio of the Balance of Payment (as % of service exports) of 2006 in Latin America(all income levels) to that in Latin America(developing only)?
Offer a very short reply. 0.97. What is the ratio of the Balance of Payment (as % of service exports) in 2008 in Latin America(all income levels) to that in Latin America(developing only)?
Give a very brief answer. 0.98. What is the difference between the highest and the second highest Balance of Payment (as % of service exports) in 2005?
Provide a succinct answer. 1.49. What is the difference between the highest and the second highest Balance of Payment (as % of service exports) of 2006?
Make the answer very short. 1.29. What is the difference between the highest and the second highest Balance of Payment (as % of service exports) in 2007?
Provide a short and direct response. 0.55. What is the difference between the highest and the second highest Balance of Payment (as % of service exports) in 2008?
Provide a succinct answer. 0.94. What is the difference between the highest and the lowest Balance of Payment (as % of service exports) of 2005?
Provide a succinct answer. 26.09. What is the difference between the highest and the lowest Balance of Payment (as % of service exports) in 2006?
Ensure brevity in your answer.  25.88. What is the difference between the highest and the lowest Balance of Payment (as % of service exports) of 2007?
Your answer should be compact. 23.58. What is the difference between the highest and the lowest Balance of Payment (as % of service exports) in 2008?
Your response must be concise. 22.23. 